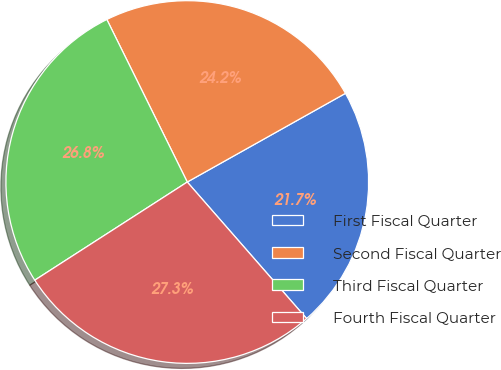Convert chart. <chart><loc_0><loc_0><loc_500><loc_500><pie_chart><fcel>First Fiscal Quarter<fcel>Second Fiscal Quarter<fcel>Third Fiscal Quarter<fcel>Fourth Fiscal Quarter<nl><fcel>21.7%<fcel>24.18%<fcel>26.79%<fcel>27.33%<nl></chart> 